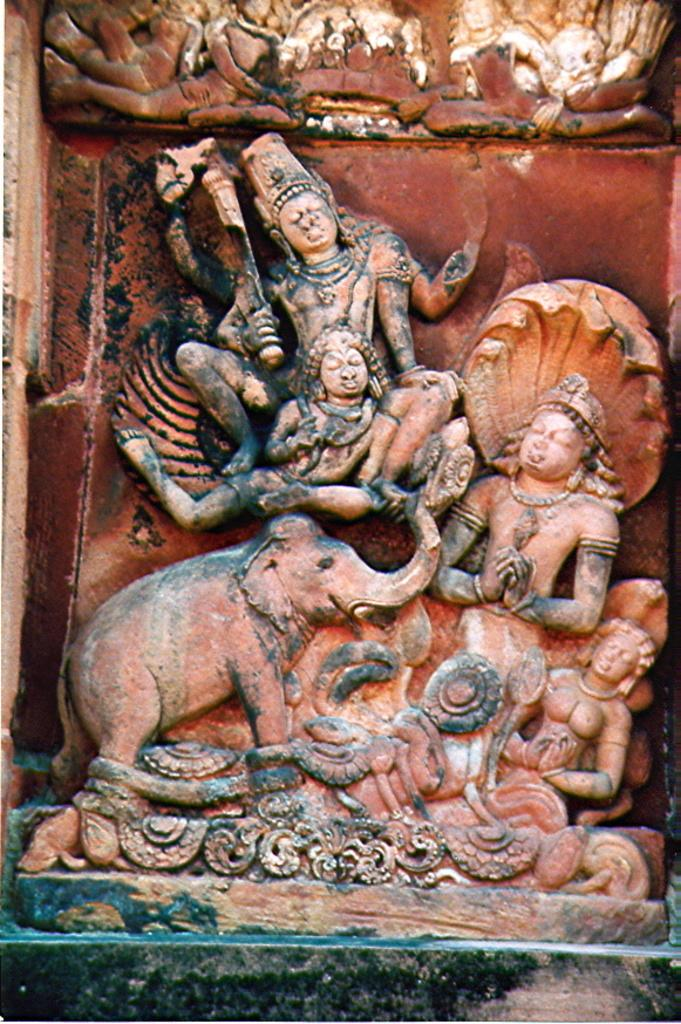What is the main subject in the image? There is a carved stone of idols in the image. What type of game is the father playing with the cat in the image? There is no father or cat present in the image; it features a carved stone of idols. 